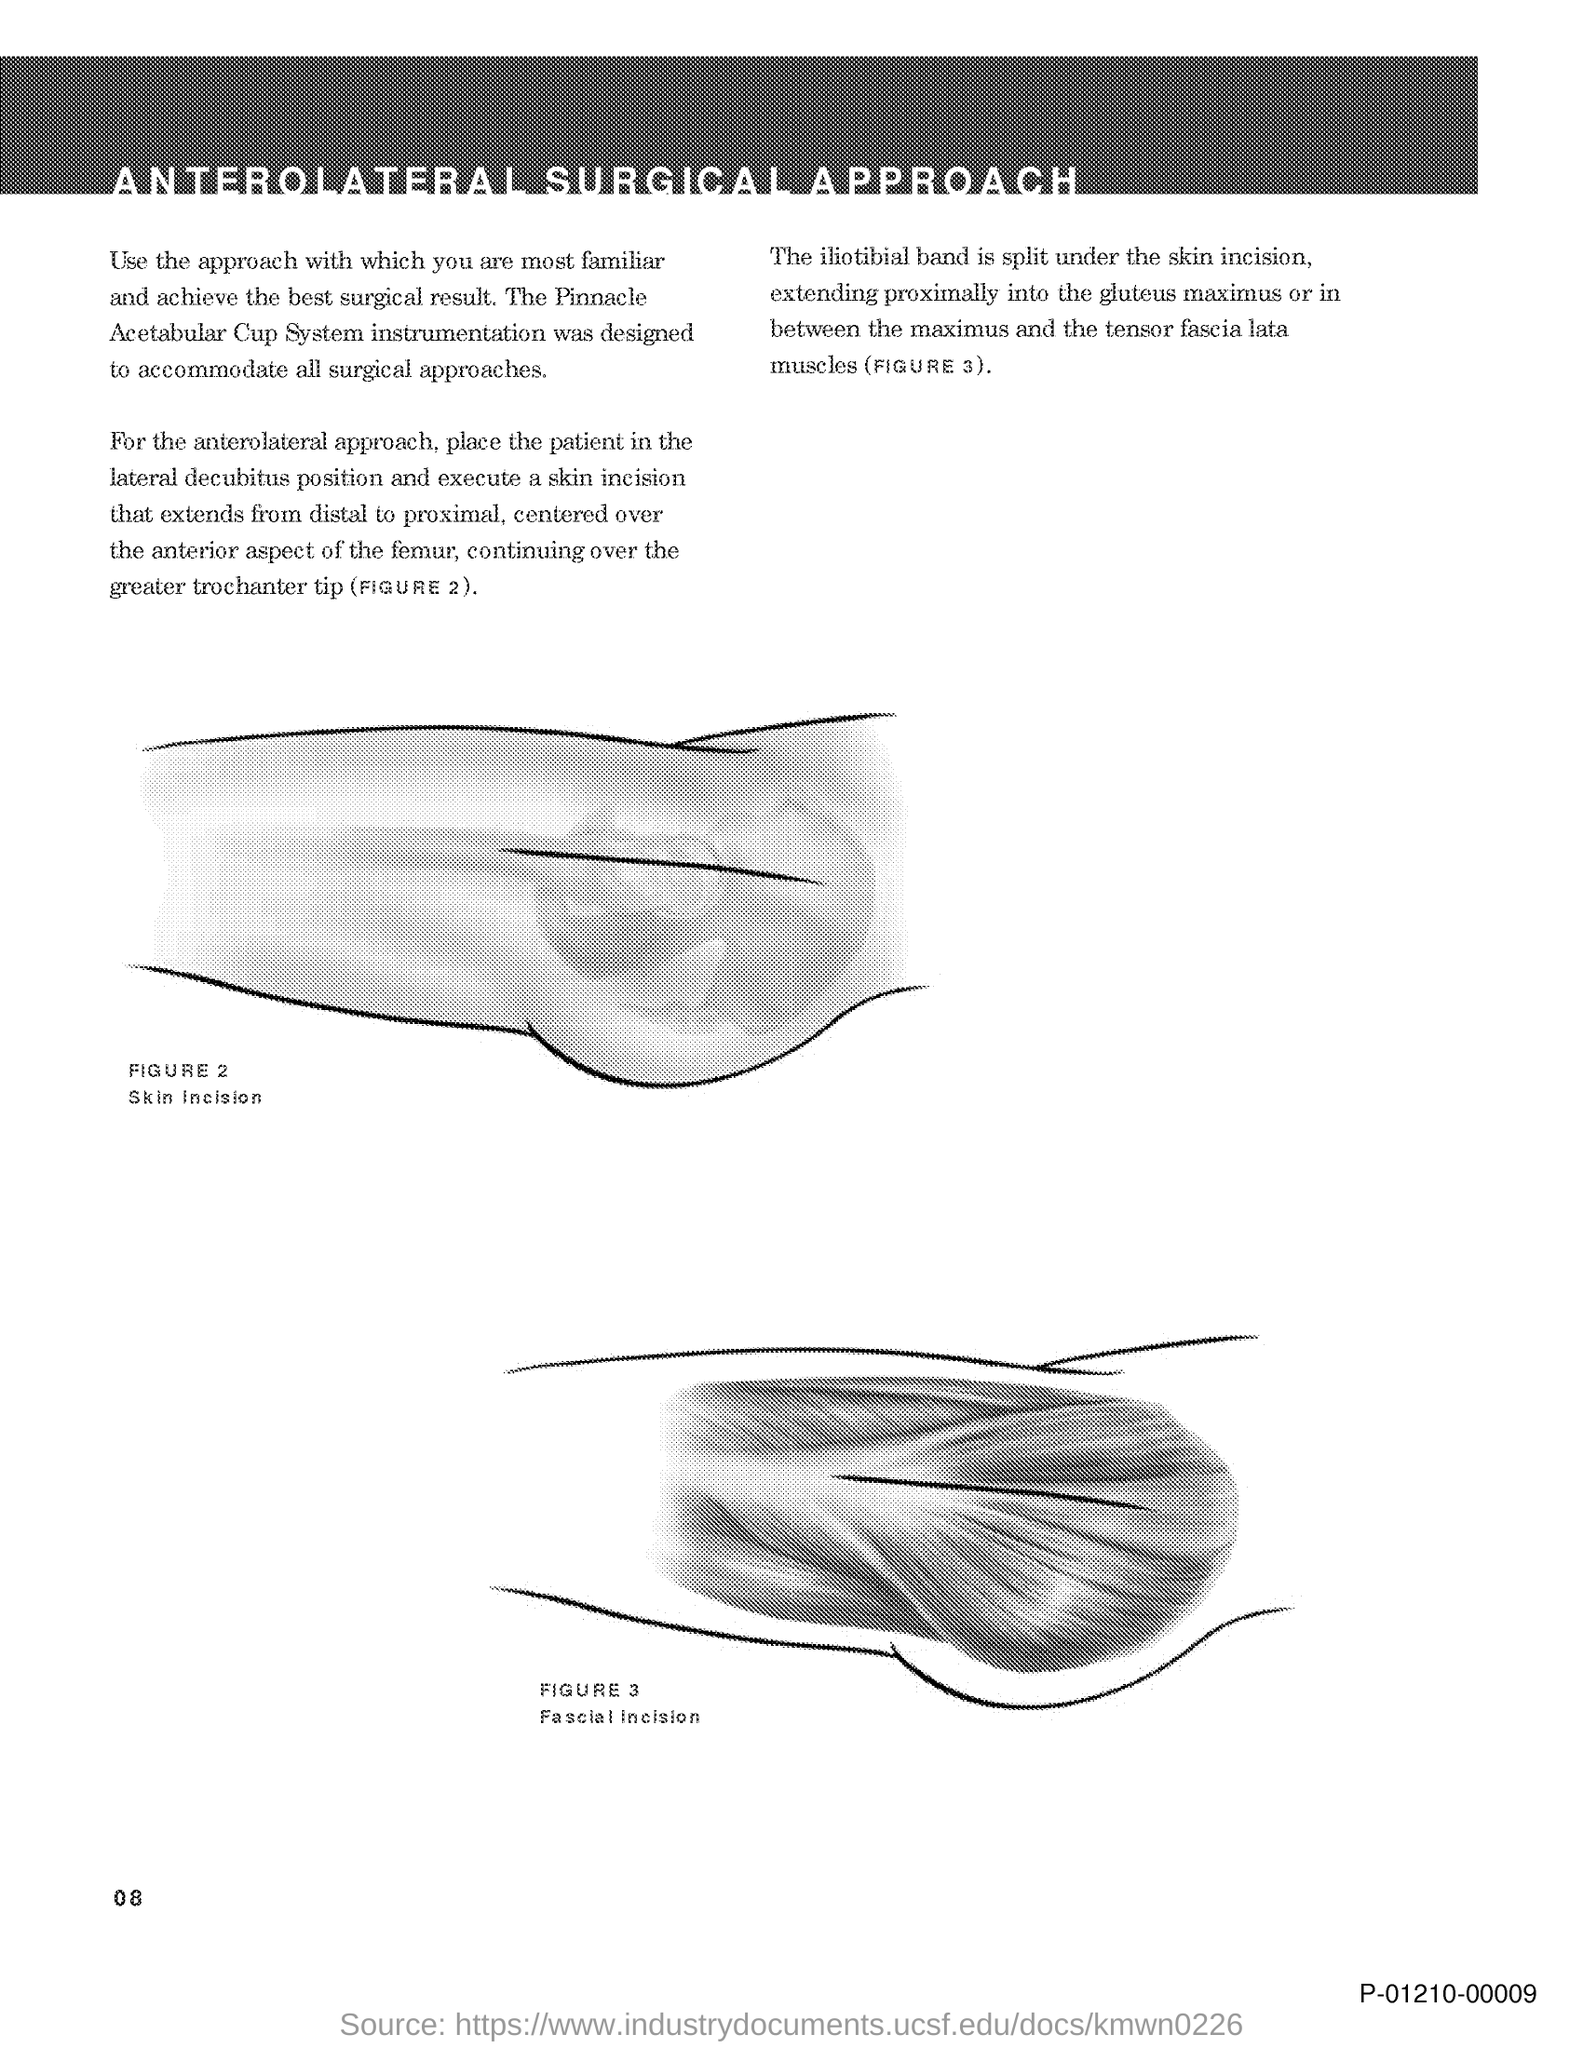What is the title of the document?
Your response must be concise. Anterolateral Surgical Approach. 